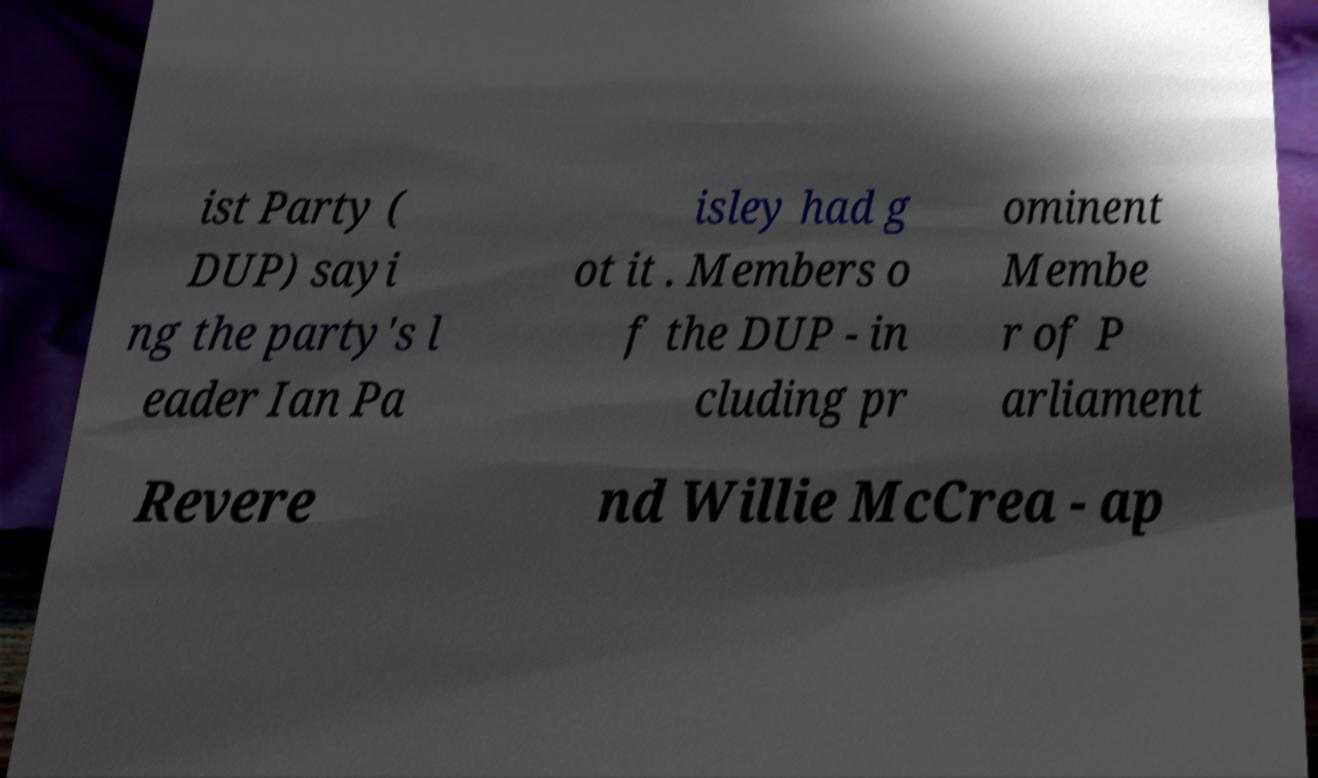Please identify and transcribe the text found in this image. ist Party ( DUP) sayi ng the party's l eader Ian Pa isley had g ot it . Members o f the DUP - in cluding pr ominent Membe r of P arliament Revere nd Willie McCrea - ap 